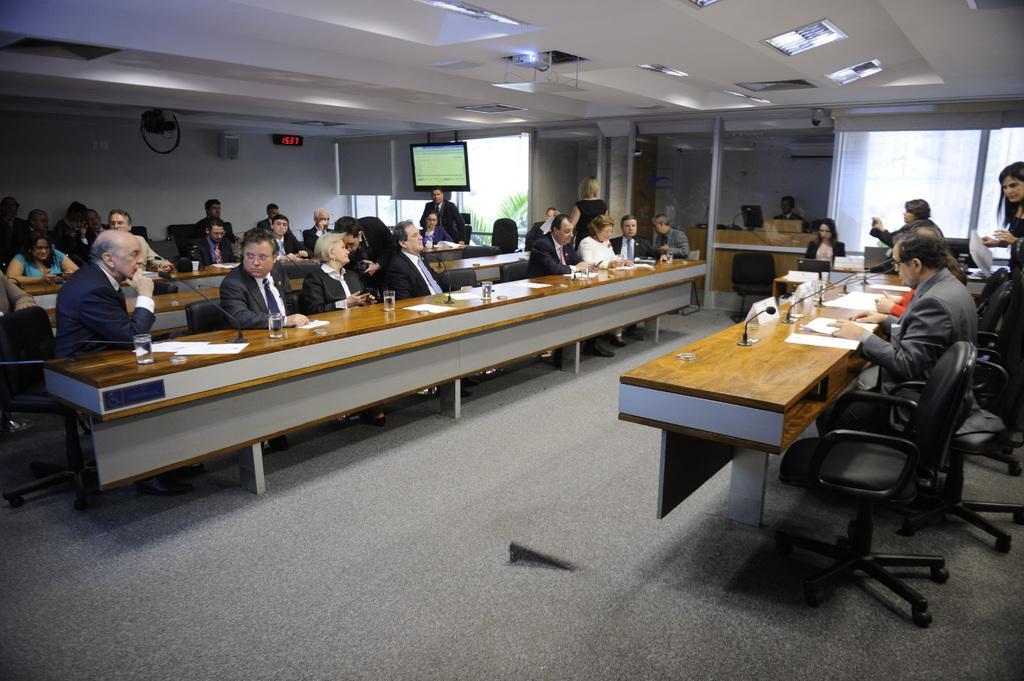Please provide a concise description of this image. This picture describes about group of people some people seated on the chairs and some are standing, in front of them we can find papers and microphones on the table, and also we can find monitor and couple of trees. 